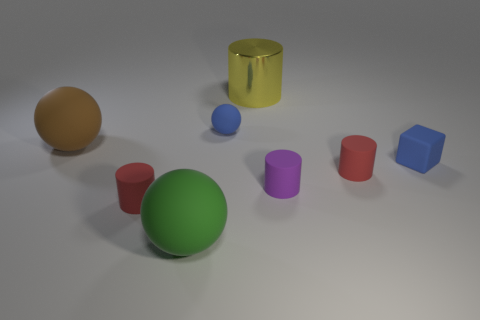Is there anything else that is the same size as the purple matte cylinder?
Provide a succinct answer. Yes. What is the size of the cylinder behind the brown ball?
Offer a very short reply. Large. What number of big green balls have the same material as the brown ball?
Provide a succinct answer. 1. There is a big matte object that is to the right of the brown thing; is it the same shape as the shiny thing?
Keep it short and to the point. No. What is the shape of the blue thing that is left of the tiny purple rubber cylinder?
Give a very brief answer. Sphere. The ball that is the same color as the tiny matte cube is what size?
Offer a terse response. Small. What is the material of the big brown ball?
Offer a terse response. Rubber. There is a cube that is the same size as the blue sphere; what is its color?
Provide a succinct answer. Blue. There is a rubber object that is the same color as the tiny block; what is its shape?
Give a very brief answer. Sphere. Does the brown thing have the same shape as the yellow object?
Offer a terse response. No. 